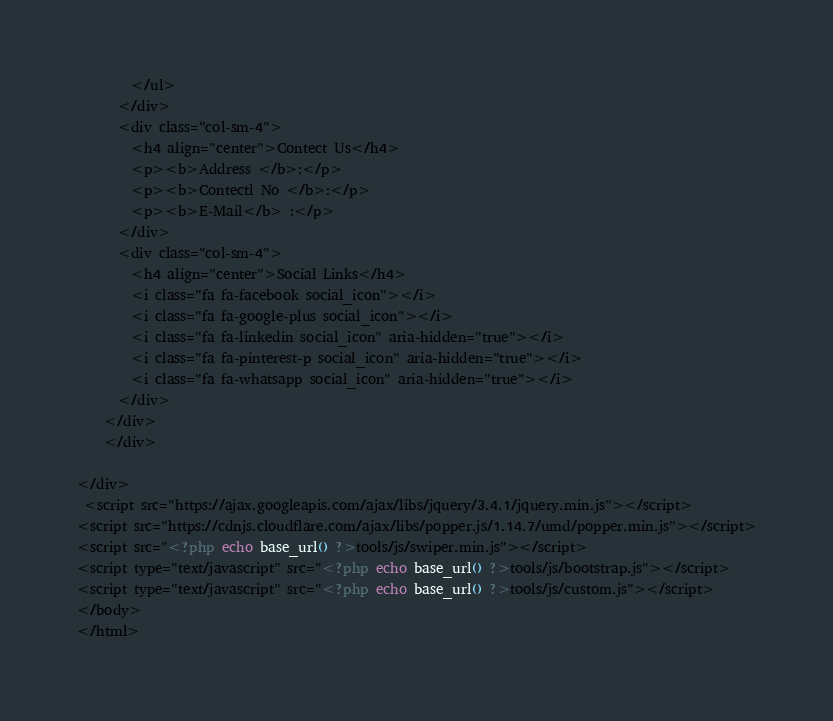<code> <loc_0><loc_0><loc_500><loc_500><_PHP_>        </ul>
      </div>
      <div class="col-sm-4">
        <h4 align="center">Contect Us</h4>
        <p><b>Address </b>:</p>
        <p><b>Contectl No </b>:</p>
        <p><b>E-Mail</b> :</p>
      </div>
      <div class="col-sm-4">
        <h4 align="center">Social Links</h4>
        <i class="fa fa-facebook social_icon"></i>
        <i class="fa fa-google-plus social_icon"></i>
        <i class="fa fa-linkedin social_icon" aria-hidden="true"></i>
        <i class="fa fa-pinterest-p social_icon" aria-hidden="true"></i>
        <i class="fa fa-whatsapp social_icon" aria-hidden="true"></i>
      </div>
    </div>
    </div>

</div>
 <script src="https://ajax.googleapis.com/ajax/libs/jquery/3.4.1/jquery.min.js"></script>
<script src="https://cdnjs.cloudflare.com/ajax/libs/popper.js/1.14.7/umd/popper.min.js"></script>
<script src="<?php echo base_url() ?>tools/js/swiper.min.js"></script>
<script type="text/javascript" src="<?php echo base_url() ?>tools/js/bootstrap.js"></script>
<script type="text/javascript" src="<?php echo base_url() ?>tools/js/custom.js"></script>
</body>
</html></code> 